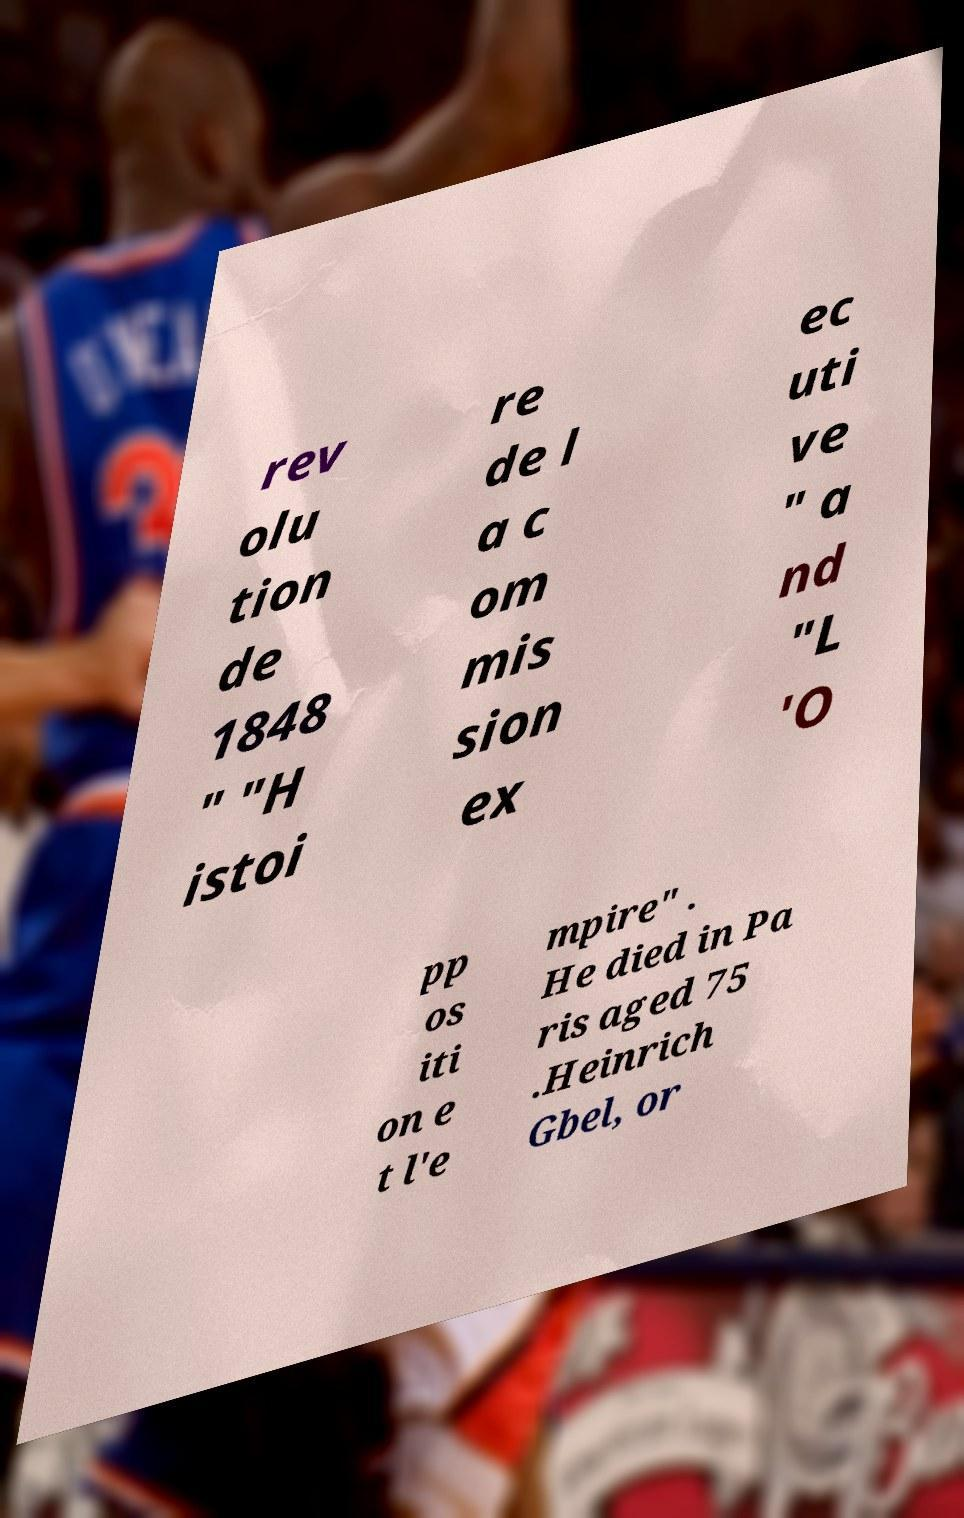Can you read and provide the text displayed in the image?This photo seems to have some interesting text. Can you extract and type it out for me? rev olu tion de 1848 " "H istoi re de l a c om mis sion ex ec uti ve " a nd "L 'O pp os iti on e t l'e mpire" . He died in Pa ris aged 75 .Heinrich Gbel, or 